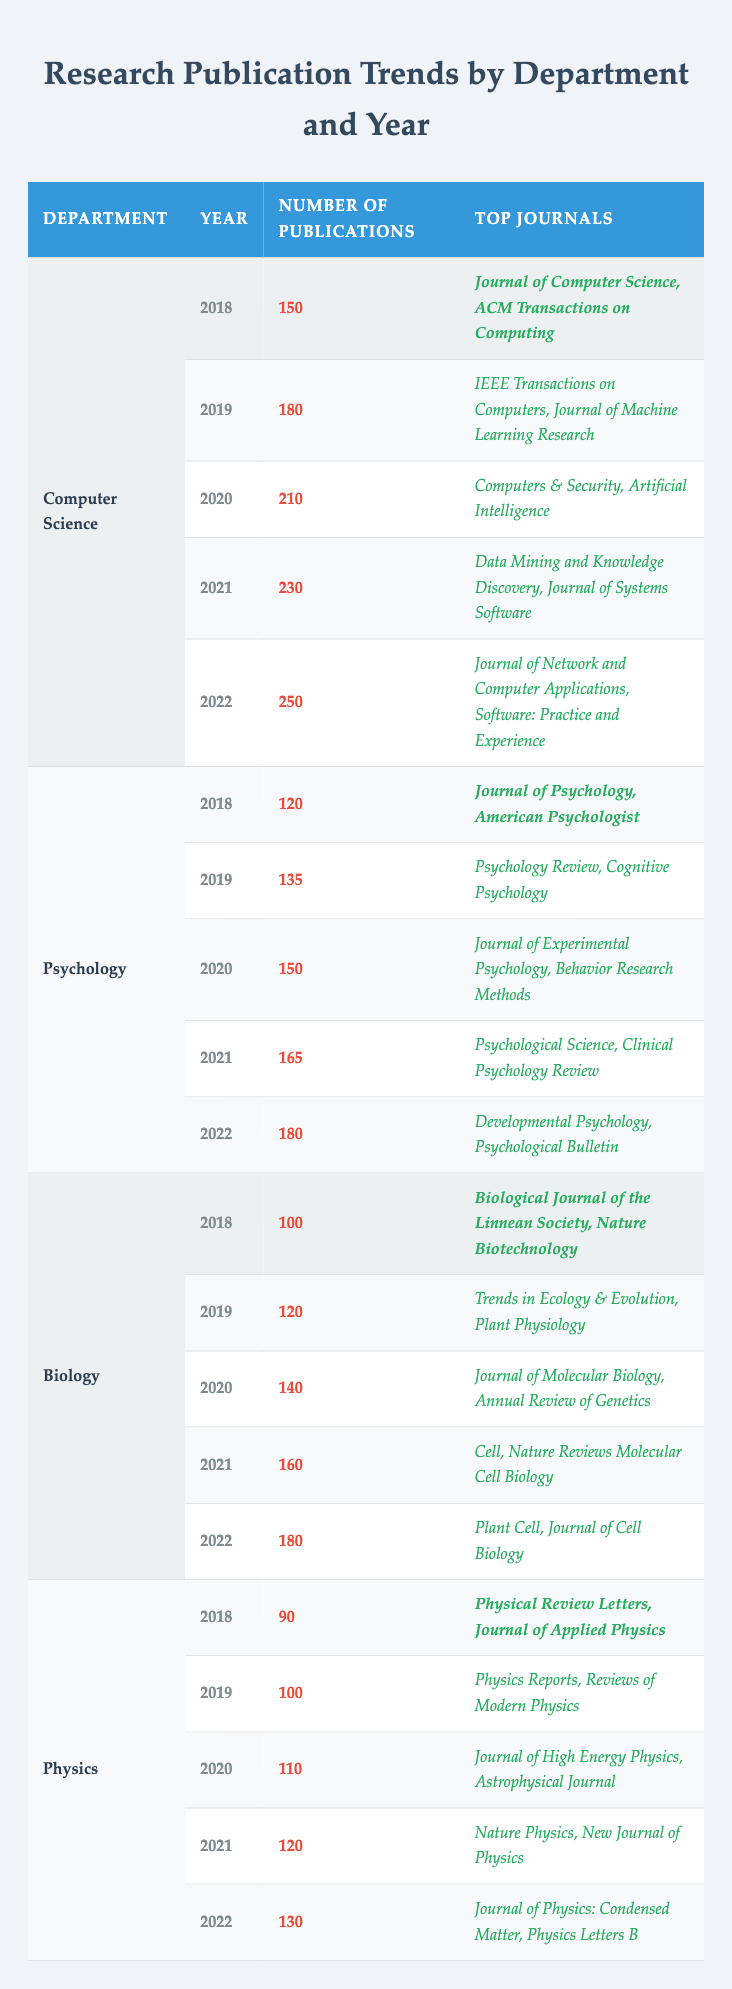What was the number of publications in Computer Science in 2021? The table shows that the number of publications for Computer Science in the year 2021 is listed directly under that year. Referring to the row for Computer Science and the year 2021, we see the value is 230.
Answer: 230 Which department had the highest number of publications in 2022? To determine which department had the highest publications in 2022, we need to compare the number of publications across all departments for that year. For Computer Science it is 250, Psychology 180, Biology 180, and Physics 130. Since 250 is the largest number, the answer is Computer Science.
Answer: Computer Science What was the average number of publications per year for Biology from 2018 to 2022? First, we identify the number of publications for Biology for each year: 100 (2018), 120 (2019), 140 (2020), 160 (2021), and 180 (2022). Next, we sum these values: 100 + 120 + 140 + 160 + 180 = 700. Finally, we divide by the number of years, which is 5, thus 700 / 5 = 140.
Answer: 140 Did Psychology publish more or less than 150 articles in 2020? The row for Psychology in 2020 indicates 150 publications. Since the published count equals 150, it is neither more nor less; it is exactly 150.
Answer: No Which year had the greatest increase in the number of publications for Physics? To assess the increase in publications for Physics, we look at the values year by year: 90 (2018), 100 (2019), 110 (2020), 120 (2021), and 130 (2022). The annual increases are 10 (2019-2018), 10 (2020-2019), 10 (2021-2020), and 10 (2022-2021). All increases are equal, thus we can state that every year had the same increase.
Answer: All years had equal increases What are the top two journals for Computer Science in 2020? The table lists the top two journals for each department under each year. For Computer Science in 2020, the top journals are "Computers & Security" and "Artificial Intelligence".
Answer: Computers & Security, Artificial Intelligence 